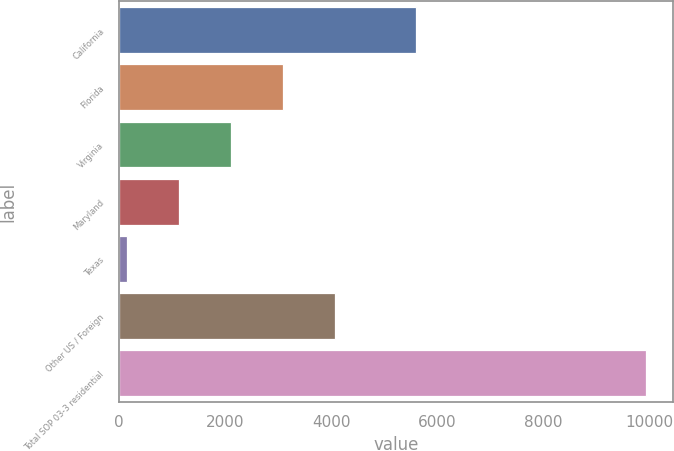Convert chart. <chart><loc_0><loc_0><loc_500><loc_500><bar_chart><fcel>California<fcel>Florida<fcel>Virginia<fcel>Maryland<fcel>Texas<fcel>Other US / Foreign<fcel>Total SOP 03-3 residential<nl><fcel>5598<fcel>3087.6<fcel>2107.4<fcel>1127.2<fcel>147<fcel>4067.8<fcel>9949<nl></chart> 